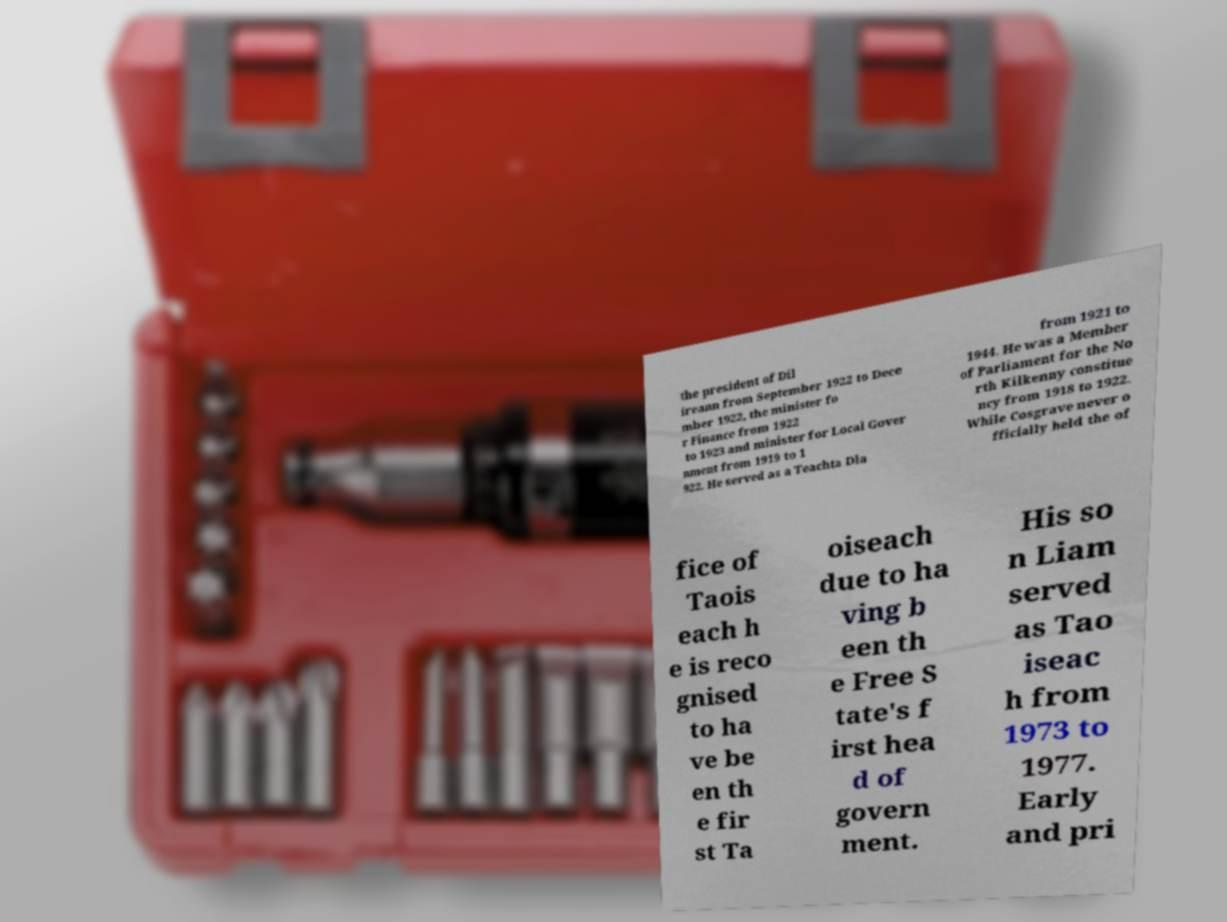Please read and relay the text visible in this image. What does it say? the president of Dil ireann from September 1922 to Dece mber 1922, the minister fo r Finance from 1922 to 1923 and minister for Local Gover nment from 1919 to 1 922. He served as a Teachta Dla from 1921 to 1944. He was a Member of Parliament for the No rth Kilkenny constitue ncy from 1918 to 1922. While Cosgrave never o fficially held the of fice of Taois each h e is reco gnised to ha ve be en th e fir st Ta oiseach due to ha ving b een th e Free S tate's f irst hea d of govern ment. His so n Liam served as Tao iseac h from 1973 to 1977. Early and pri 